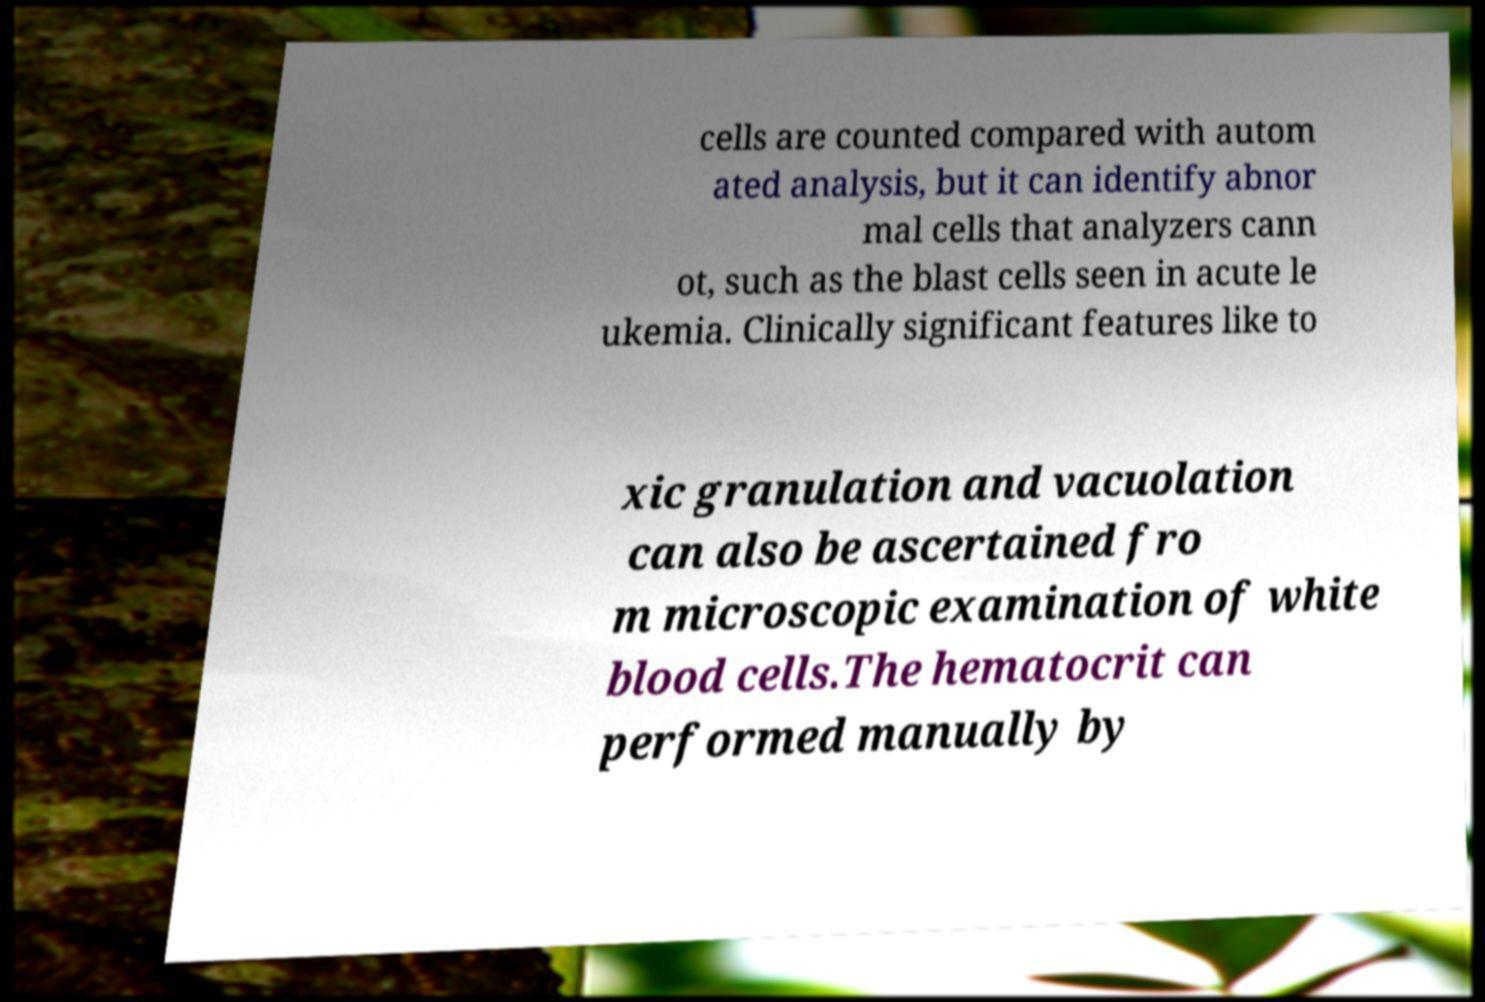Can you accurately transcribe the text from the provided image for me? cells are counted compared with autom ated analysis, but it can identify abnor mal cells that analyzers cann ot, such as the blast cells seen in acute le ukemia. Clinically significant features like to xic granulation and vacuolation can also be ascertained fro m microscopic examination of white blood cells.The hematocrit can performed manually by 